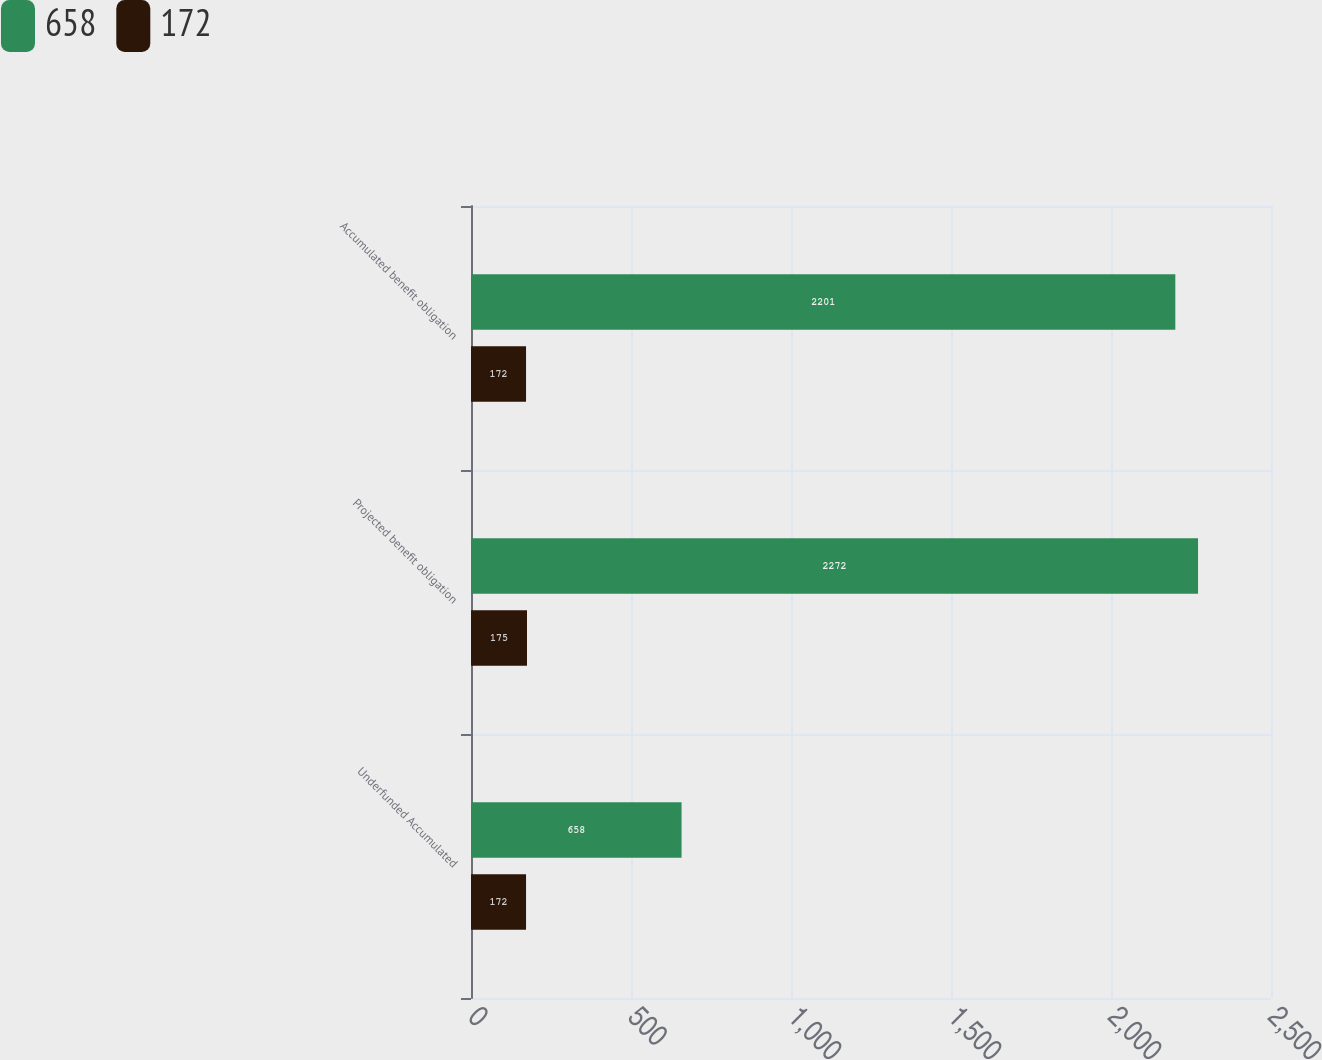Convert chart. <chart><loc_0><loc_0><loc_500><loc_500><stacked_bar_chart><ecel><fcel>Underfunded Accumulated<fcel>Projected benefit obligation<fcel>Accumulated benefit obligation<nl><fcel>658<fcel>658<fcel>2272<fcel>2201<nl><fcel>172<fcel>172<fcel>175<fcel>172<nl></chart> 